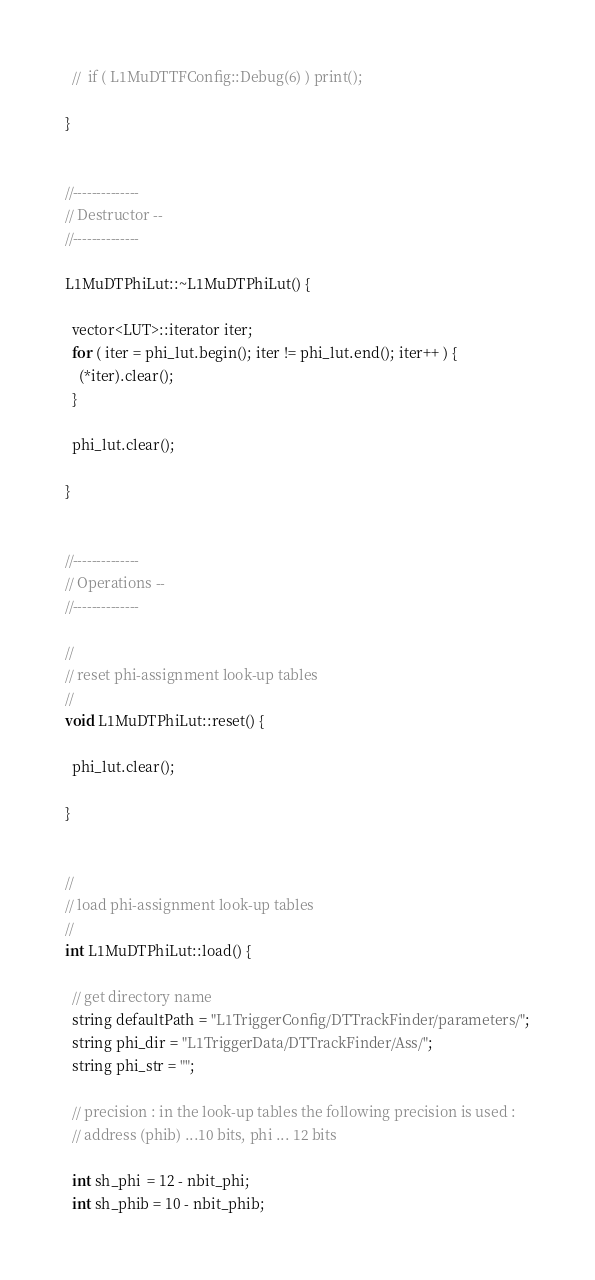Convert code to text. <code><loc_0><loc_0><loc_500><loc_500><_C++_>
  //  if ( L1MuDTTFConfig::Debug(6) ) print();

}


//--------------
// Destructor --
//--------------

L1MuDTPhiLut::~L1MuDTPhiLut() {

  vector<LUT>::iterator iter;
  for ( iter = phi_lut.begin(); iter != phi_lut.end(); iter++ ) {
    (*iter).clear();
  }

  phi_lut.clear();

}


//--------------
// Operations --
//--------------

//
// reset phi-assignment look-up tables
//
void L1MuDTPhiLut::reset() {

  phi_lut.clear();

}


//
// load phi-assignment look-up tables
//
int L1MuDTPhiLut::load() {

  // get directory name
  string defaultPath = "L1TriggerConfig/DTTrackFinder/parameters/";
  string phi_dir = "L1TriggerData/DTTrackFinder/Ass/";
  string phi_str = "";

  // precision : in the look-up tables the following precision is used :
  // address (phib) ...10 bits, phi ... 12 bits

  int sh_phi  = 12 - nbit_phi;
  int sh_phib = 10 - nbit_phib;
</code> 